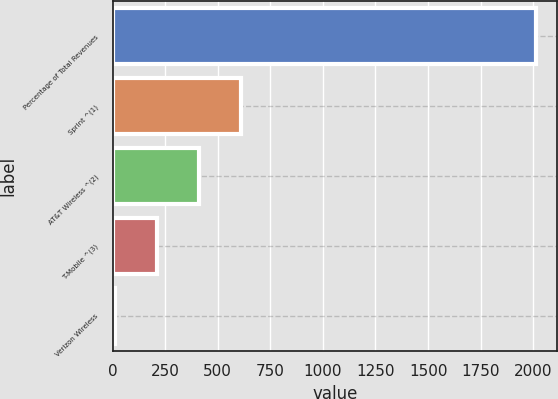Convert chart to OTSL. <chart><loc_0><loc_0><loc_500><loc_500><bar_chart><fcel>Percentage of Total Revenues<fcel>Sprint ^(1)<fcel>AT&T Wireless ^(2)<fcel>T-Mobile ^(3)<fcel>Verizon Wireless<nl><fcel>2013<fcel>611.81<fcel>411.64<fcel>211.47<fcel>11.3<nl></chart> 